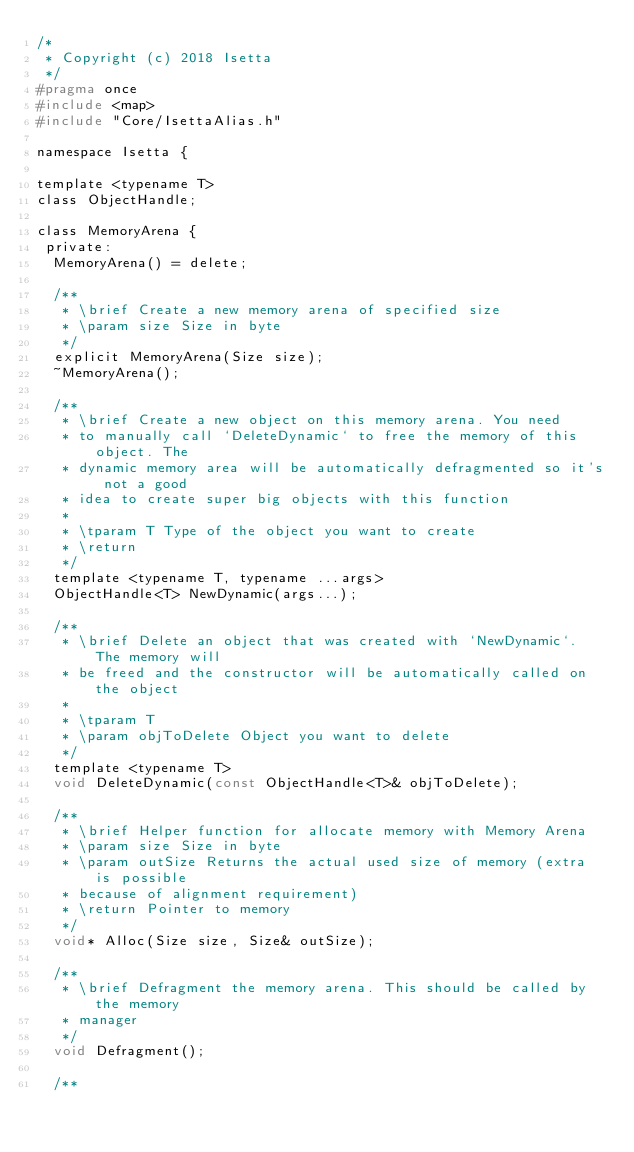Convert code to text. <code><loc_0><loc_0><loc_500><loc_500><_C_>/*
 * Copyright (c) 2018 Isetta
 */
#pragma once
#include <map>
#include "Core/IsettaAlias.h"

namespace Isetta {

template <typename T>
class ObjectHandle;

class MemoryArena {
 private:
  MemoryArena() = delete;

  /**
   * \brief Create a new memory arena of specified size
   * \param size Size in byte
   */
  explicit MemoryArena(Size size);
  ~MemoryArena();

  /**
   * \brief Create a new object on this memory arena. You need
   * to manually call `DeleteDynamic` to free the memory of this object. The
   * dynamic memory area will be automatically defragmented so it's not a good
   * idea to create super big objects with this function
   *
   * \tparam T Type of the object you want to create
   * \return
   */
  template <typename T, typename ...args>
  ObjectHandle<T> NewDynamic(args...);

  /**
   * \brief Delete an object that was created with `NewDynamic`. The memory will
   * be freed and the constructor will be automatically called on the object
   *
   * \tparam T
   * \param objToDelete Object you want to delete
   */
  template <typename T>
  void DeleteDynamic(const ObjectHandle<T>& objToDelete);

  /**
   * \brief Helper function for allocate memory with Memory Arena
   * \param size Size in byte
   * \param outSize Returns the actual used size of memory (extra is possible
   * because of alignment requirement)
   * \return Pointer to memory
   */
  void* Alloc(Size size, Size& outSize);

  /**
   * \brief Defragment the memory arena. This should be called by the memory
   * manager
   */
  void Defragment();

  /**</code> 